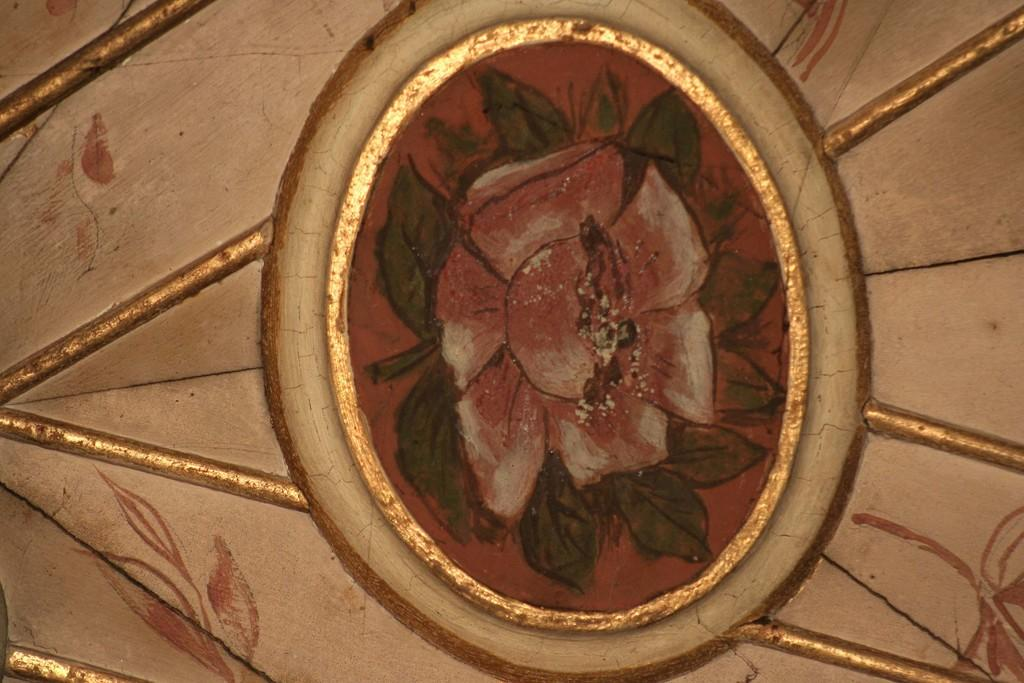What part of a house can be seen in the image? The image shows the ceiling of a house. What decorative element is present on the ceiling? There is a flower design on the ceiling. What type of rifle can be seen hanging on the wall in the image? There is no rifle present in the image; it only shows the ceiling of a house with a flower design. 